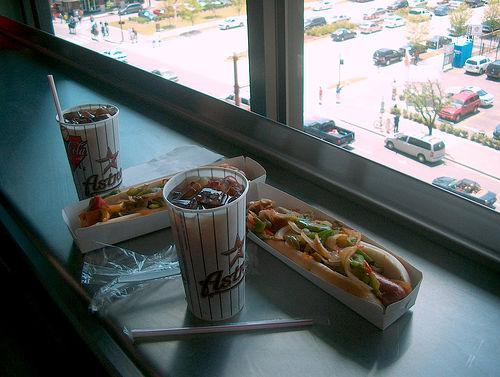How many hot dogs are shown?
Quick response, please. 2. Do both drinks have straws in them?
Be succinct. No. What is the food and drinks sitting next to?
Be succinct. Window. 